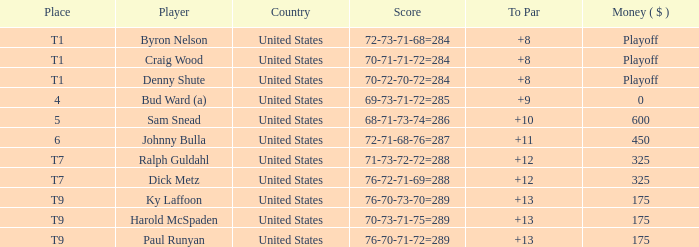What was the total To Par for Craig Wood? 8.0. 